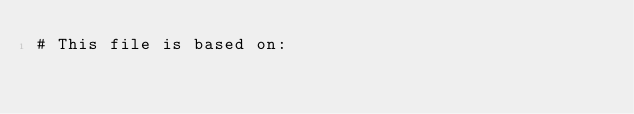Convert code to text. <code><loc_0><loc_0><loc_500><loc_500><_Python_># This file is based on:</code> 